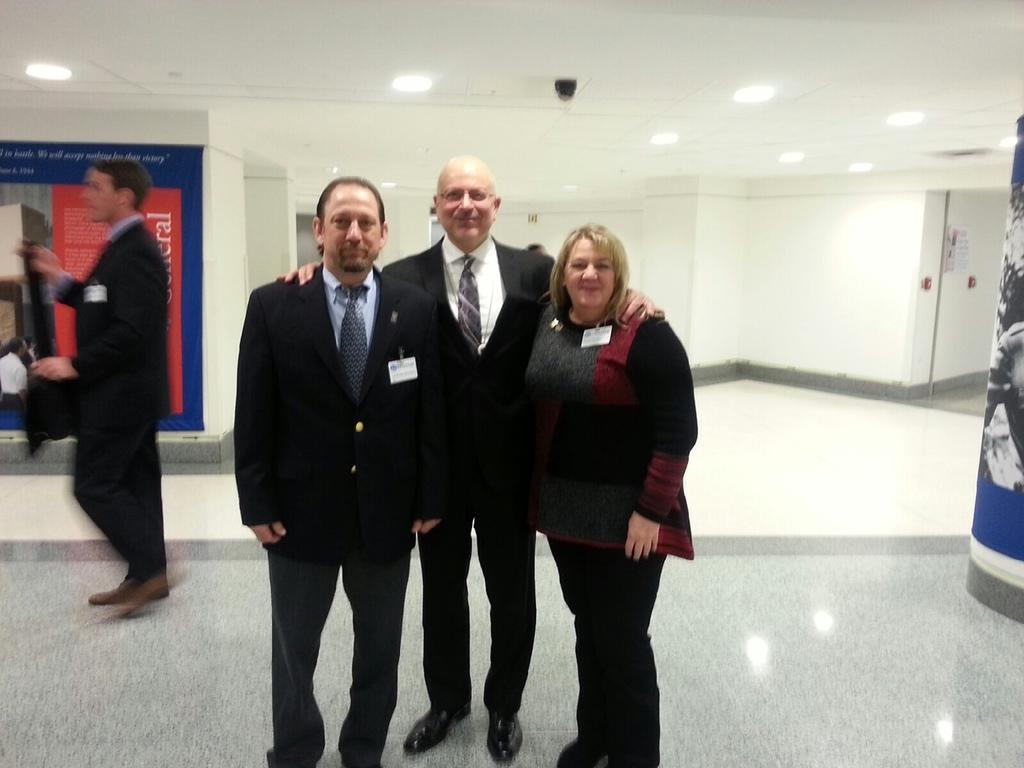Could you give a brief overview of what you see in this image? In this image we can see a few people standing and there is a poster with some text and images, on the top of the roof there are some lights and CC camera. In the background, we can see the wall. 